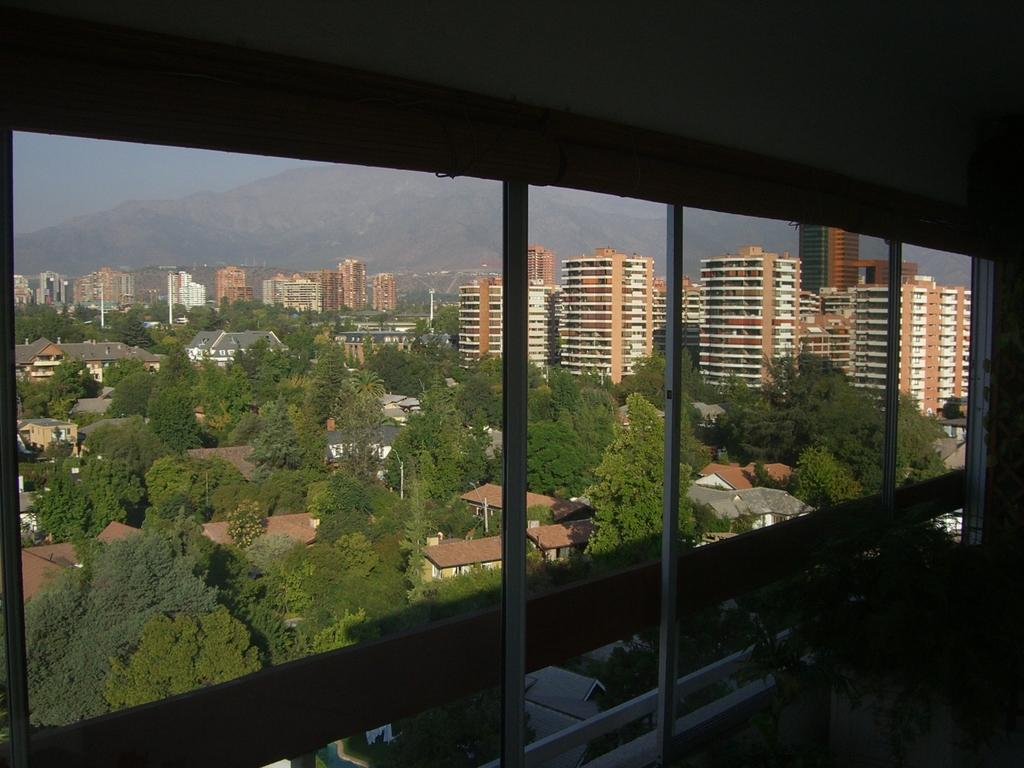What type of structures can be seen in the image? There are buildings in the image. What natural elements are present in the image? There are trees and mountains in the image. What man-made objects can be seen in the image? There are poles in the image. What architectural features are visible in the image? There is a window and a wall in the image. What part of the natural environment is visible in the image? The sky is visible in the image. Can you tell me how many whips are being used in the hall depicted in the image? There is no hall or whip present in the image. Is there a fight taking place in the image? There is no fight depicted in the image. 